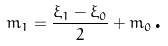Convert formula to latex. <formula><loc_0><loc_0><loc_500><loc_500>m _ { 1 } = \frac { \xi _ { 1 } - \xi _ { 0 } } { 2 } + m _ { 0 } \text {.}</formula> 